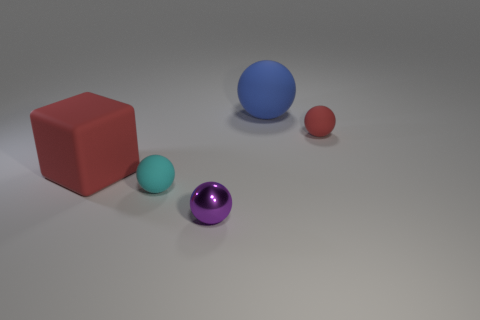Are there an equal number of matte cubes that are in front of the metallic ball and red matte balls in front of the cyan ball?
Offer a terse response. Yes. What number of other objects are the same material as the red ball?
Your answer should be compact. 3. What number of small things are blue matte objects or red matte spheres?
Provide a succinct answer. 1. Are there an equal number of big rubber balls in front of the big cube and big cylinders?
Offer a terse response. Yes. Are there any rubber things that are right of the large object that is on the left side of the tiny cyan thing?
Offer a terse response. Yes. How many other things are the same color as the large rubber block?
Your response must be concise. 1. What is the color of the small metal object?
Your response must be concise. Purple. How big is the thing that is in front of the red block and on the left side of the small purple metal thing?
Ensure brevity in your answer.  Small. How many objects are either large things to the left of the cyan rubber thing or large green metallic objects?
Make the answer very short. 1. There is a red thing that is made of the same material as the small red sphere; what is its shape?
Give a very brief answer. Cube. 